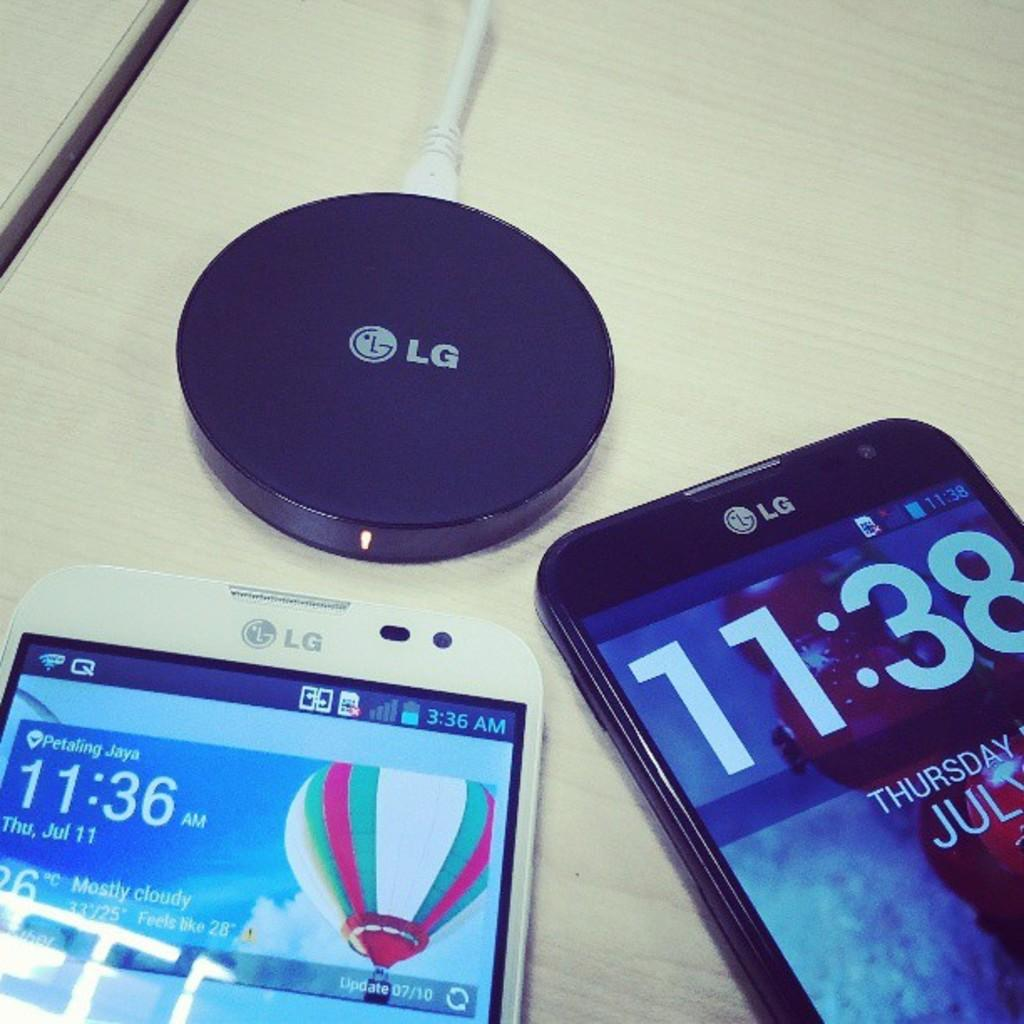<image>
Provide a brief description of the given image. Two LG phones are sitting below a plugged in LG charger. 